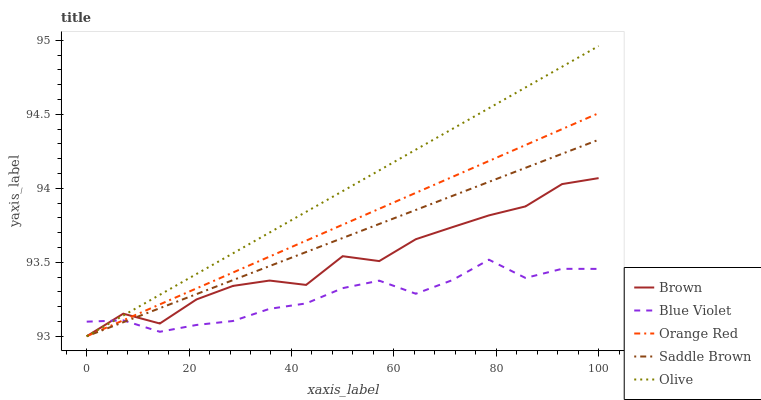Does Blue Violet have the minimum area under the curve?
Answer yes or no. Yes. Does Olive have the maximum area under the curve?
Answer yes or no. Yes. Does Brown have the minimum area under the curve?
Answer yes or no. No. Does Brown have the maximum area under the curve?
Answer yes or no. No. Is Saddle Brown the smoothest?
Answer yes or no. Yes. Is Brown the roughest?
Answer yes or no. Yes. Is Orange Red the smoothest?
Answer yes or no. No. Is Orange Red the roughest?
Answer yes or no. No. Does Olive have the lowest value?
Answer yes or no. Yes. Does Blue Violet have the lowest value?
Answer yes or no. No. Does Olive have the highest value?
Answer yes or no. Yes. Does Brown have the highest value?
Answer yes or no. No. Does Blue Violet intersect Orange Red?
Answer yes or no. Yes. Is Blue Violet less than Orange Red?
Answer yes or no. No. Is Blue Violet greater than Orange Red?
Answer yes or no. No. 